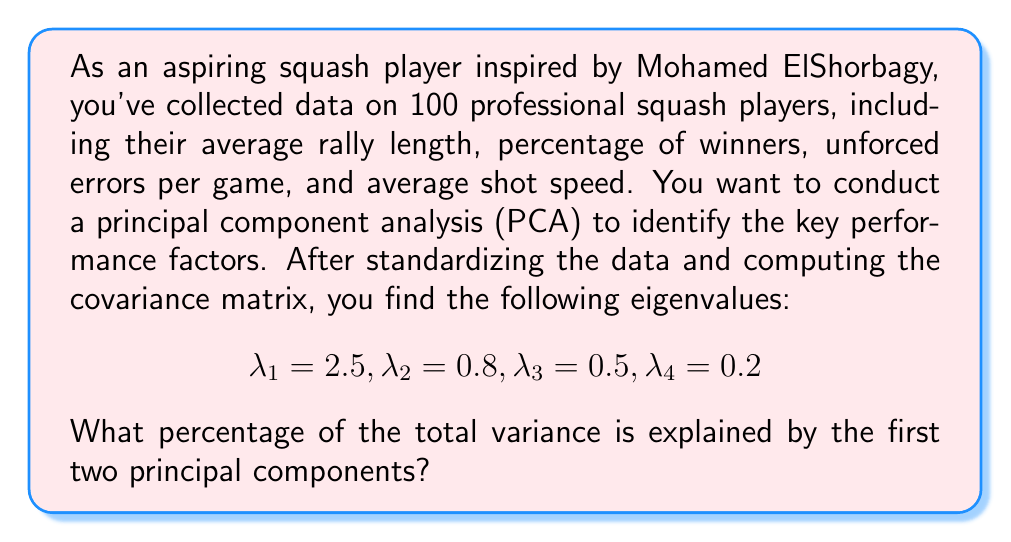Solve this math problem. To solve this problem, we need to follow these steps:

1) In PCA, each eigenvalue represents the amount of variance explained by its corresponding principal component.

2) The total variance is the sum of all eigenvalues:
   $$\text{Total Variance} = \sum_{i=1}^n \lambda_i = 2.5 + 0.8 + 0.5 + 0.2 = 4$$

3) The variance explained by the first two principal components is the sum of their corresponding eigenvalues:
   $$\text{Variance of PC1 and PC2} = \lambda_1 + \lambda_2 = 2.5 + 0.8 = 3.3$$

4) To calculate the percentage of variance explained, we divide the variance of the first two PCs by the total variance and multiply by 100:

   $$\text{Percentage} = \frac{\text{Variance of PC1 and PC2}}{\text{Total Variance}} \times 100\%$$

   $$= \frac{3.3}{4} \times 100\% = 0.825 \times 100\% = 82.5\%$$

Therefore, the first two principal components explain 82.5% of the total variance in the squash player statistics.
Answer: 82.5% 